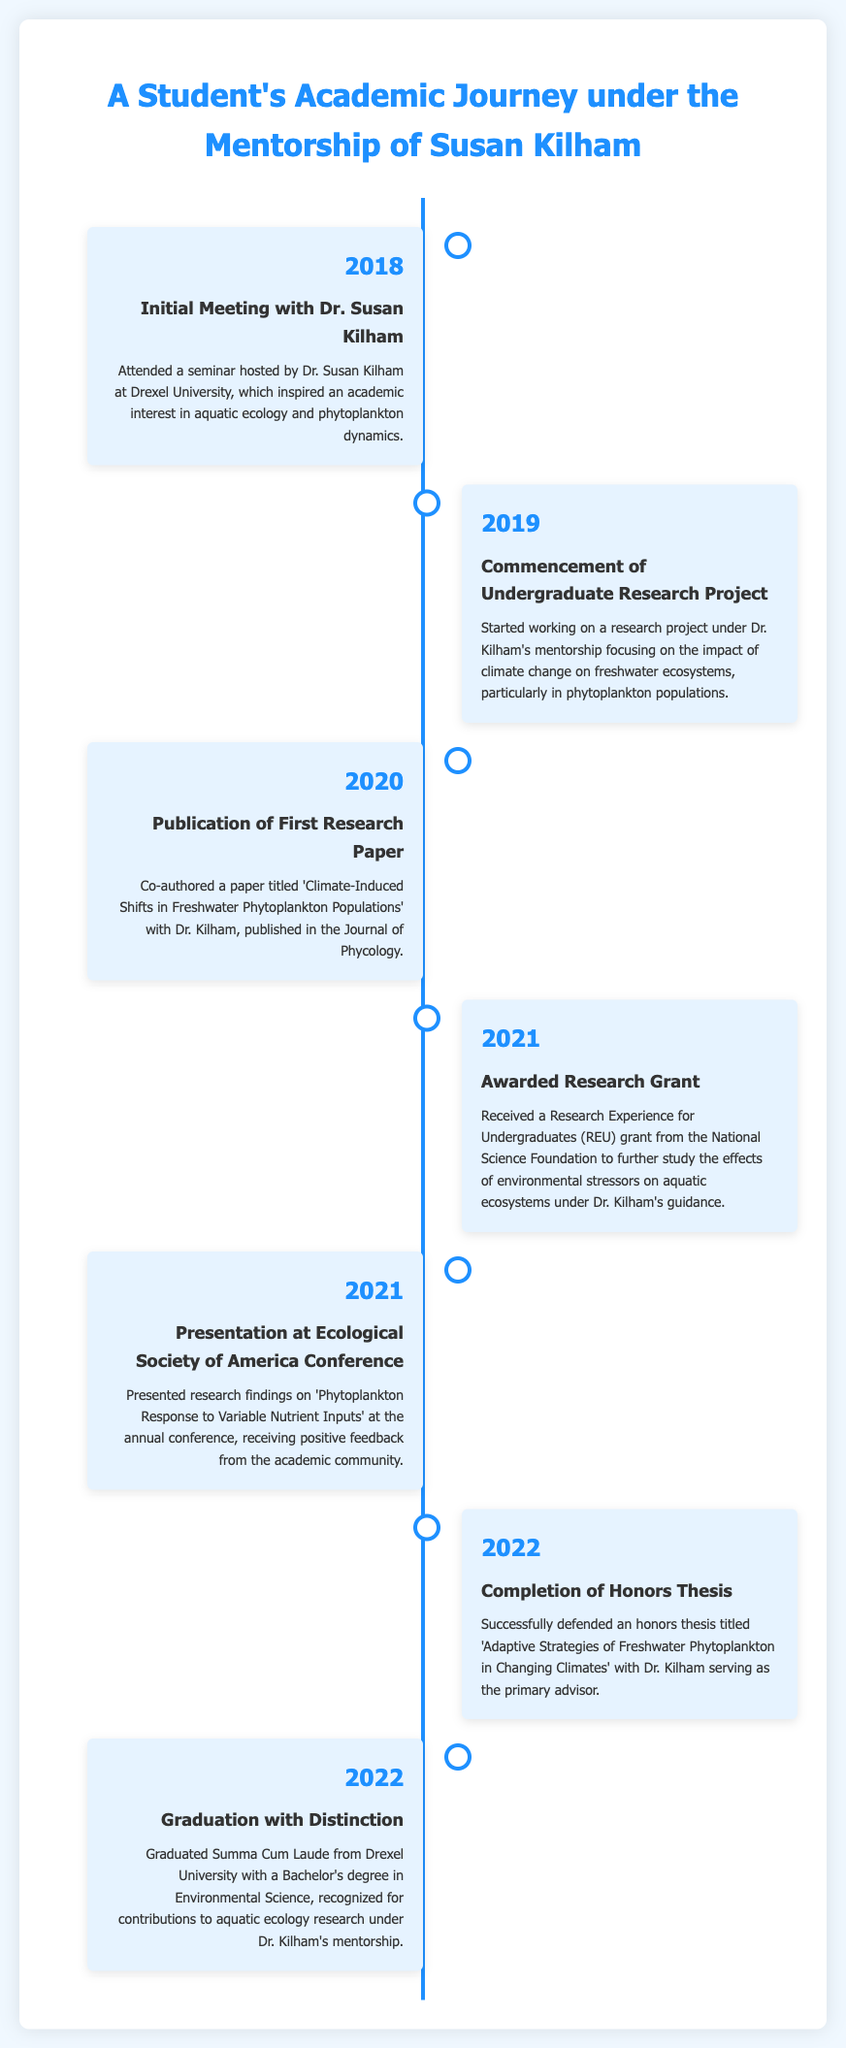What year did the student first meet Dr. Kilham? The document states that the initial meeting occurred in 2018.
Answer: 2018 What was the title of the student's first research paper? The title of the paper co-authored with Dr. Kilham is 'Climate-Induced Shifts in Freshwater Phytoplankton Populations.'
Answer: Climate-Induced Shifts in Freshwater Phytoplankton Populations How many research-related events occurred in 2021? The document lists two significant events in 2021: the awarded grant and the conference presentation.
Answer: 2 What degree did the student graduate with? The document states that the student graduated with a Bachelor's degree in Environmental Science.
Answer: Bachelor's degree in Environmental Science Who served as the primary advisor for the student's honors thesis? The document indicates that Dr. Kilham served as the primary advisor for the honors thesis.
Answer: Dr. Kilham What significant award did the student receive in 2021? The document mentions that the student received a Research Experience for Undergraduates (REU) grant from the National Science Foundation.
Answer: REU grant When was the honors thesis successfully defended? The document states that the honors thesis was completed in 2022.
Answer: 2022 What academic honor did the student achieve upon graduation? The document specifies that the student graduated Summa Cum Laude.
Answer: Summa Cum Laude At which conference did the student present their research findings? The document notes that the student presented at the Ecological Society of America Conference.
Answer: Ecological Society of America Conference 